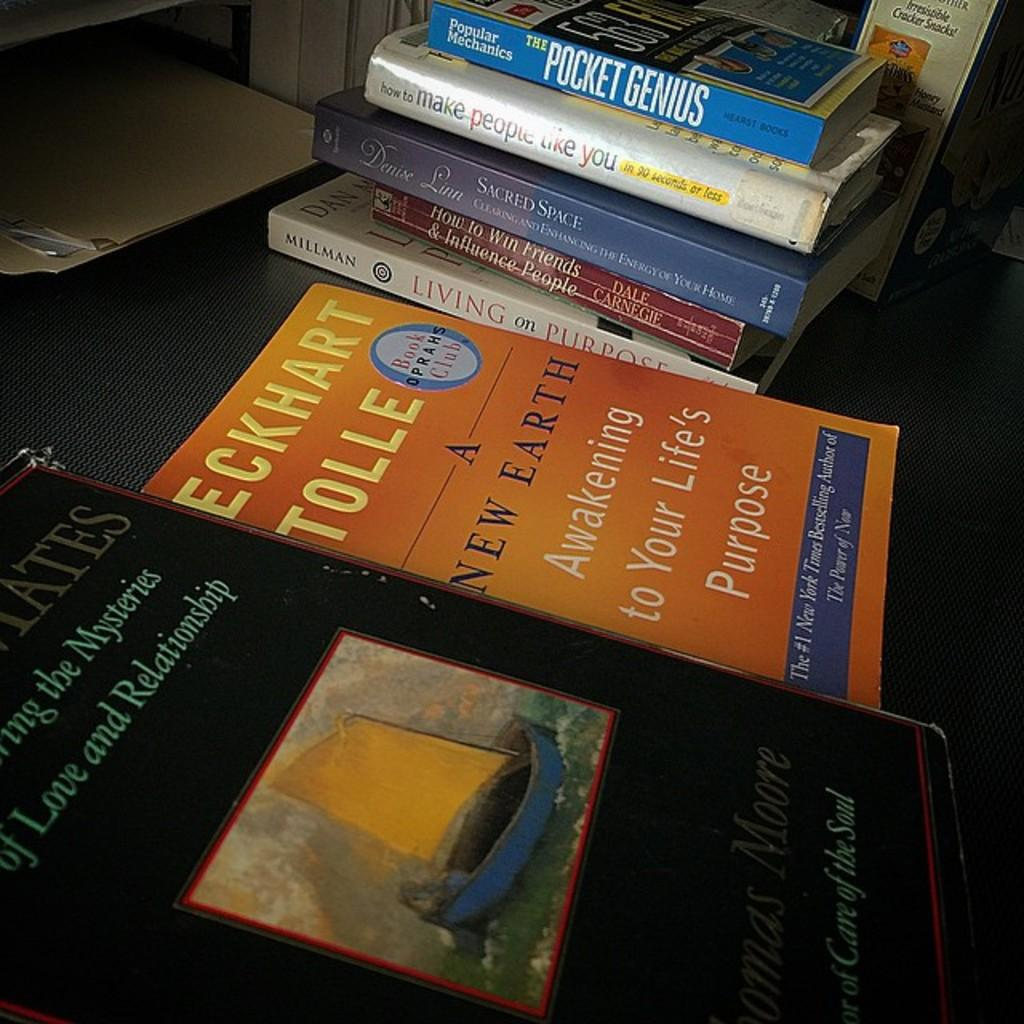<image>
Write a terse but informative summary of the picture. Several books are on a table, one is a book by Eckhart Tolle 